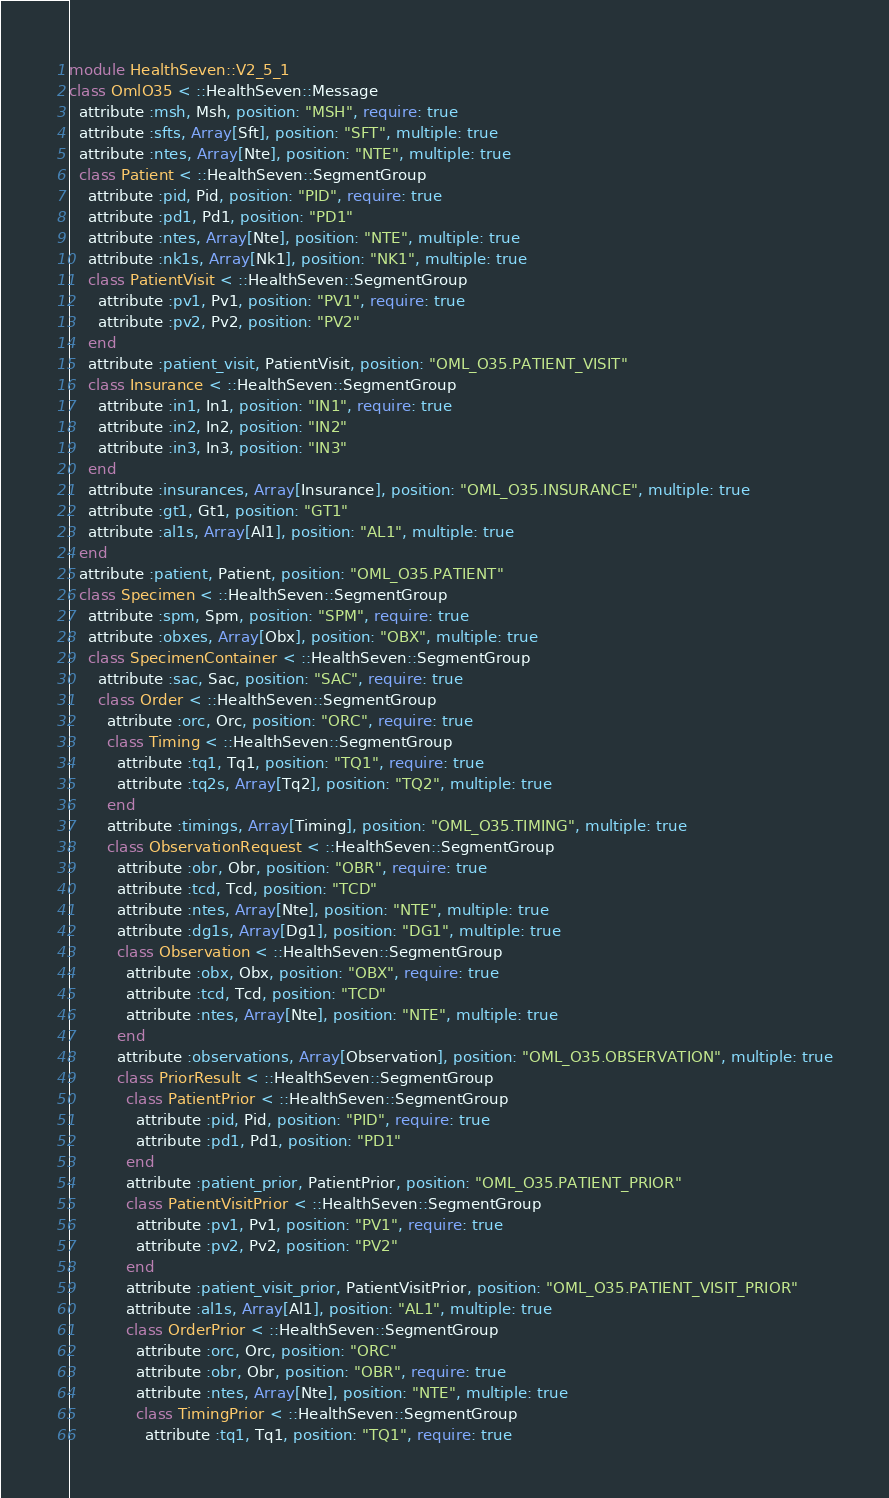Convert code to text. <code><loc_0><loc_0><loc_500><loc_500><_Ruby_>module HealthSeven::V2_5_1
class OmlO35 < ::HealthSeven::Message
  attribute :msh, Msh, position: "MSH", require: true
  attribute :sfts, Array[Sft], position: "SFT", multiple: true
  attribute :ntes, Array[Nte], position: "NTE", multiple: true
  class Patient < ::HealthSeven::SegmentGroup
    attribute :pid, Pid, position: "PID", require: true
    attribute :pd1, Pd1, position: "PD1"
    attribute :ntes, Array[Nte], position: "NTE", multiple: true
    attribute :nk1s, Array[Nk1], position: "NK1", multiple: true
    class PatientVisit < ::HealthSeven::SegmentGroup
      attribute :pv1, Pv1, position: "PV1", require: true
      attribute :pv2, Pv2, position: "PV2"
    end
    attribute :patient_visit, PatientVisit, position: "OML_O35.PATIENT_VISIT"
    class Insurance < ::HealthSeven::SegmentGroup
      attribute :in1, In1, position: "IN1", require: true
      attribute :in2, In2, position: "IN2"
      attribute :in3, In3, position: "IN3"
    end
    attribute :insurances, Array[Insurance], position: "OML_O35.INSURANCE", multiple: true
    attribute :gt1, Gt1, position: "GT1"
    attribute :al1s, Array[Al1], position: "AL1", multiple: true
  end
  attribute :patient, Patient, position: "OML_O35.PATIENT"
  class Specimen < ::HealthSeven::SegmentGroup
    attribute :spm, Spm, position: "SPM", require: true
    attribute :obxes, Array[Obx], position: "OBX", multiple: true
    class SpecimenContainer < ::HealthSeven::SegmentGroup
      attribute :sac, Sac, position: "SAC", require: true
      class Order < ::HealthSeven::SegmentGroup
        attribute :orc, Orc, position: "ORC", require: true
        class Timing < ::HealthSeven::SegmentGroup
          attribute :tq1, Tq1, position: "TQ1", require: true
          attribute :tq2s, Array[Tq2], position: "TQ2", multiple: true
        end
        attribute :timings, Array[Timing], position: "OML_O35.TIMING", multiple: true
        class ObservationRequest < ::HealthSeven::SegmentGroup
          attribute :obr, Obr, position: "OBR", require: true
          attribute :tcd, Tcd, position: "TCD"
          attribute :ntes, Array[Nte], position: "NTE", multiple: true
          attribute :dg1s, Array[Dg1], position: "DG1", multiple: true
          class Observation < ::HealthSeven::SegmentGroup
            attribute :obx, Obx, position: "OBX", require: true
            attribute :tcd, Tcd, position: "TCD"
            attribute :ntes, Array[Nte], position: "NTE", multiple: true
          end
          attribute :observations, Array[Observation], position: "OML_O35.OBSERVATION", multiple: true
          class PriorResult < ::HealthSeven::SegmentGroup
            class PatientPrior < ::HealthSeven::SegmentGroup
              attribute :pid, Pid, position: "PID", require: true
              attribute :pd1, Pd1, position: "PD1"
            end
            attribute :patient_prior, PatientPrior, position: "OML_O35.PATIENT_PRIOR"
            class PatientVisitPrior < ::HealthSeven::SegmentGroup
              attribute :pv1, Pv1, position: "PV1", require: true
              attribute :pv2, Pv2, position: "PV2"
            end
            attribute :patient_visit_prior, PatientVisitPrior, position: "OML_O35.PATIENT_VISIT_PRIOR"
            attribute :al1s, Array[Al1], position: "AL1", multiple: true
            class OrderPrior < ::HealthSeven::SegmentGroup
              attribute :orc, Orc, position: "ORC"
              attribute :obr, Obr, position: "OBR", require: true
              attribute :ntes, Array[Nte], position: "NTE", multiple: true
              class TimingPrior < ::HealthSeven::SegmentGroup
                attribute :tq1, Tq1, position: "TQ1", require: true</code> 